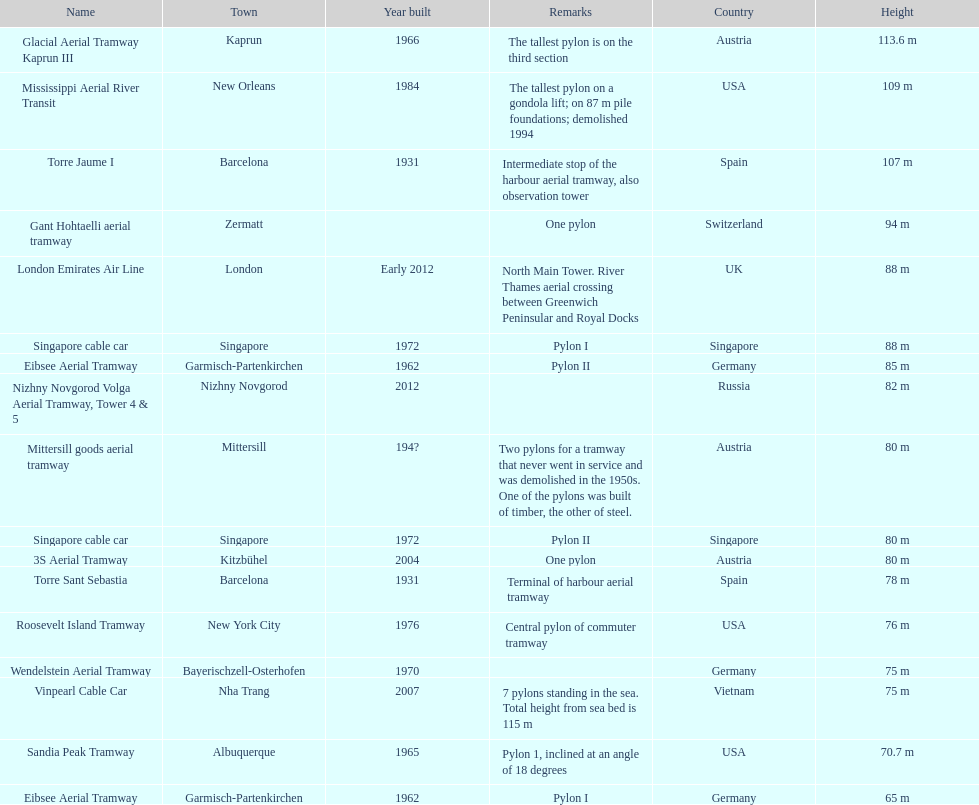How many metres is the mississippi aerial river transit from bottom to top? 109 m. Would you be able to parse every entry in this table? {'header': ['Name', 'Town', 'Year built', 'Remarks', 'Country', 'Height'], 'rows': [['Glacial Aerial Tramway Kaprun III', 'Kaprun', '1966', 'The tallest pylon is on the third section', 'Austria', '113.6 m'], ['Mississippi Aerial River Transit', 'New Orleans', '1984', 'The tallest pylon on a gondola lift; on 87 m pile foundations; demolished 1994', 'USA', '109 m'], ['Torre Jaume I', 'Barcelona', '1931', 'Intermediate stop of the harbour aerial tramway, also observation tower', 'Spain', '107 m'], ['Gant Hohtaelli aerial tramway', 'Zermatt', '', 'One pylon', 'Switzerland', '94 m'], ['London Emirates Air Line', 'London', 'Early 2012', 'North Main Tower. River Thames aerial crossing between Greenwich Peninsular and Royal Docks', 'UK', '88 m'], ['Singapore cable car', 'Singapore', '1972', 'Pylon I', 'Singapore', '88 m'], ['Eibsee Aerial Tramway', 'Garmisch-Partenkirchen', '1962', 'Pylon II', 'Germany', '85 m'], ['Nizhny Novgorod Volga Aerial Tramway, Tower 4 & 5', 'Nizhny Novgorod', '2012', '', 'Russia', '82 m'], ['Mittersill goods aerial tramway', 'Mittersill', '194?', 'Two pylons for a tramway that never went in service and was demolished in the 1950s. One of the pylons was built of timber, the other of steel.', 'Austria', '80 m'], ['Singapore cable car', 'Singapore', '1972', 'Pylon II', 'Singapore', '80 m'], ['3S Aerial Tramway', 'Kitzbühel', '2004', 'One pylon', 'Austria', '80 m'], ['Torre Sant Sebastia', 'Barcelona', '1931', 'Terminal of harbour aerial tramway', 'Spain', '78 m'], ['Roosevelt Island Tramway', 'New York City', '1976', 'Central pylon of commuter tramway', 'USA', '76 m'], ['Wendelstein Aerial Tramway', 'Bayerischzell-Osterhofen', '1970', '', 'Germany', '75 m'], ['Vinpearl Cable Car', 'Nha Trang', '2007', '7 pylons standing in the sea. Total height from sea bed is 115 m', 'Vietnam', '75 m'], ['Sandia Peak Tramway', 'Albuquerque', '1965', 'Pylon 1, inclined at an angle of 18 degrees', 'USA', '70.7 m'], ['Eibsee Aerial Tramway', 'Garmisch-Partenkirchen', '1962', 'Pylon I', 'Germany', '65 m']]} 